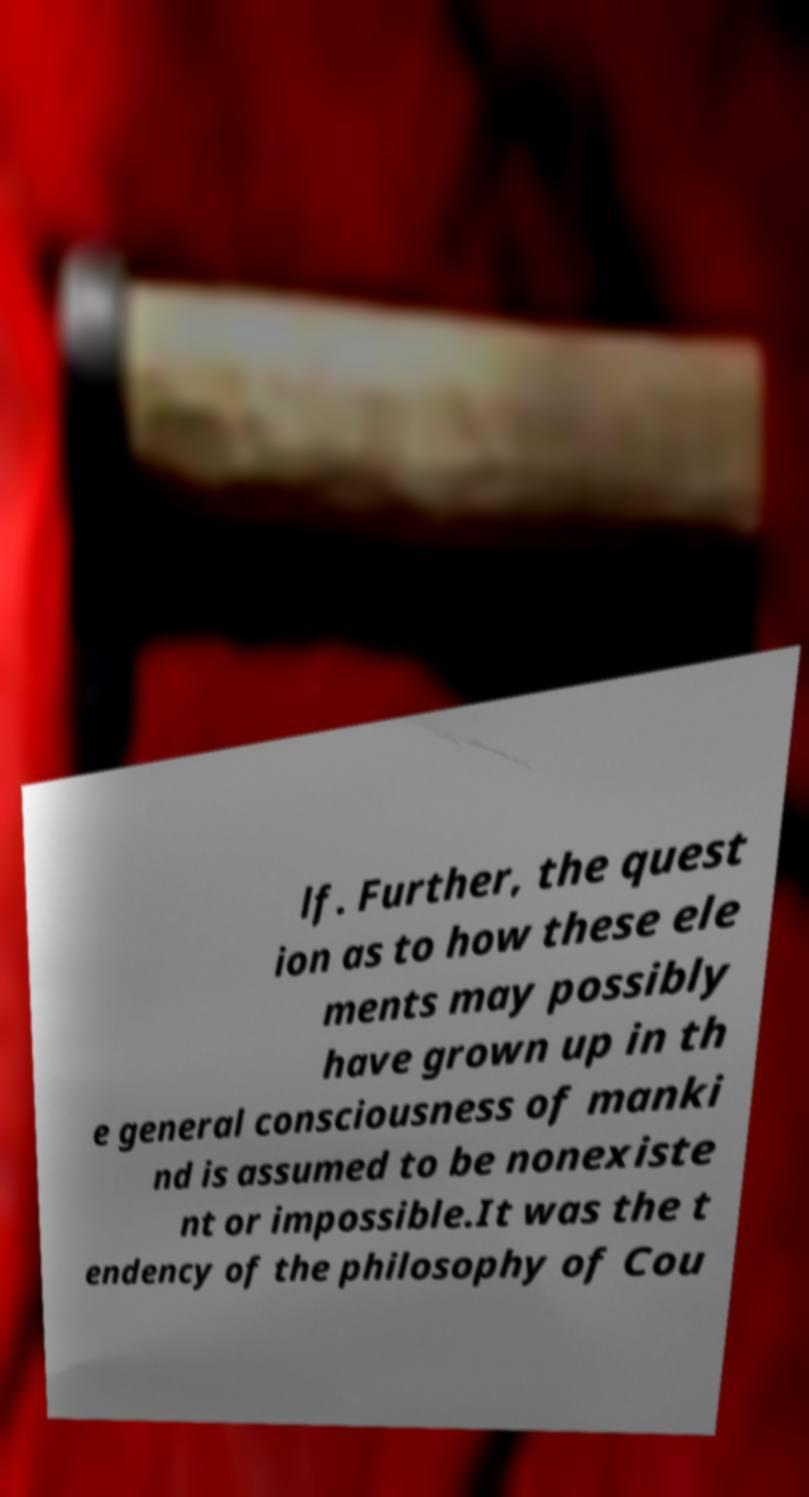Could you extract and type out the text from this image? lf. Further, the quest ion as to how these ele ments may possibly have grown up in th e general consciousness of manki nd is assumed to be nonexiste nt or impossible.It was the t endency of the philosophy of Cou 